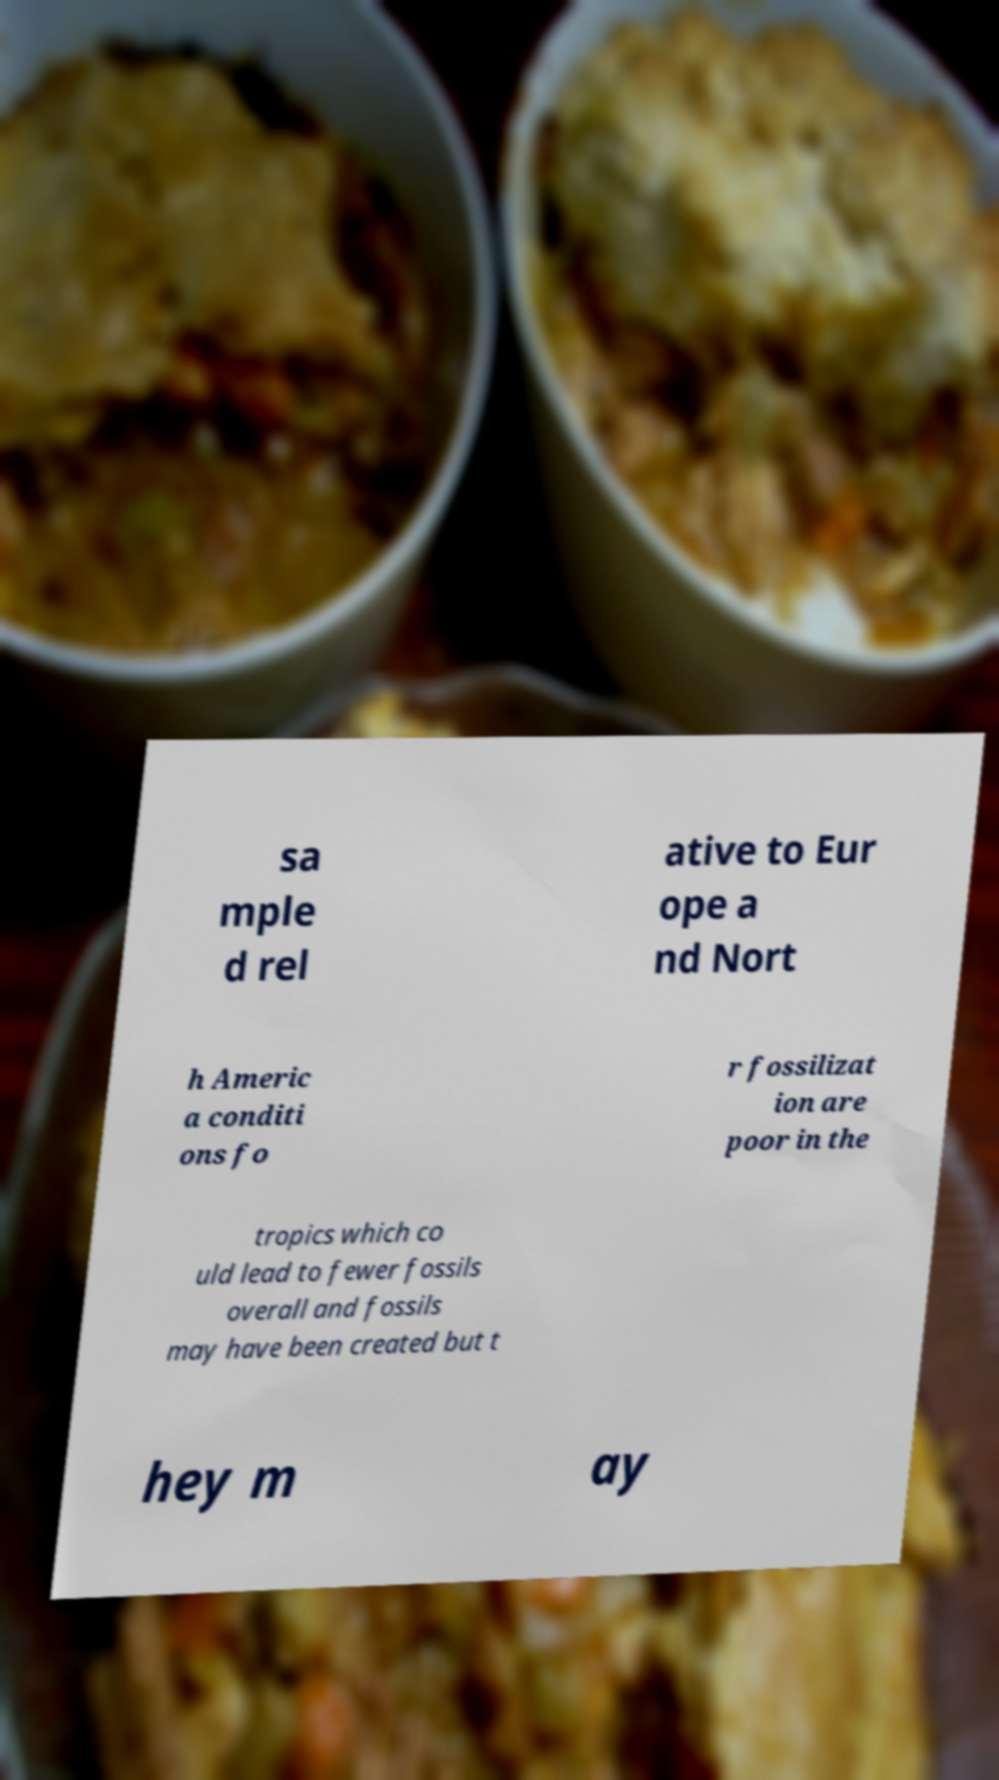Could you extract and type out the text from this image? sa mple d rel ative to Eur ope a nd Nort h Americ a conditi ons fo r fossilizat ion are poor in the tropics which co uld lead to fewer fossils overall and fossils may have been created but t hey m ay 